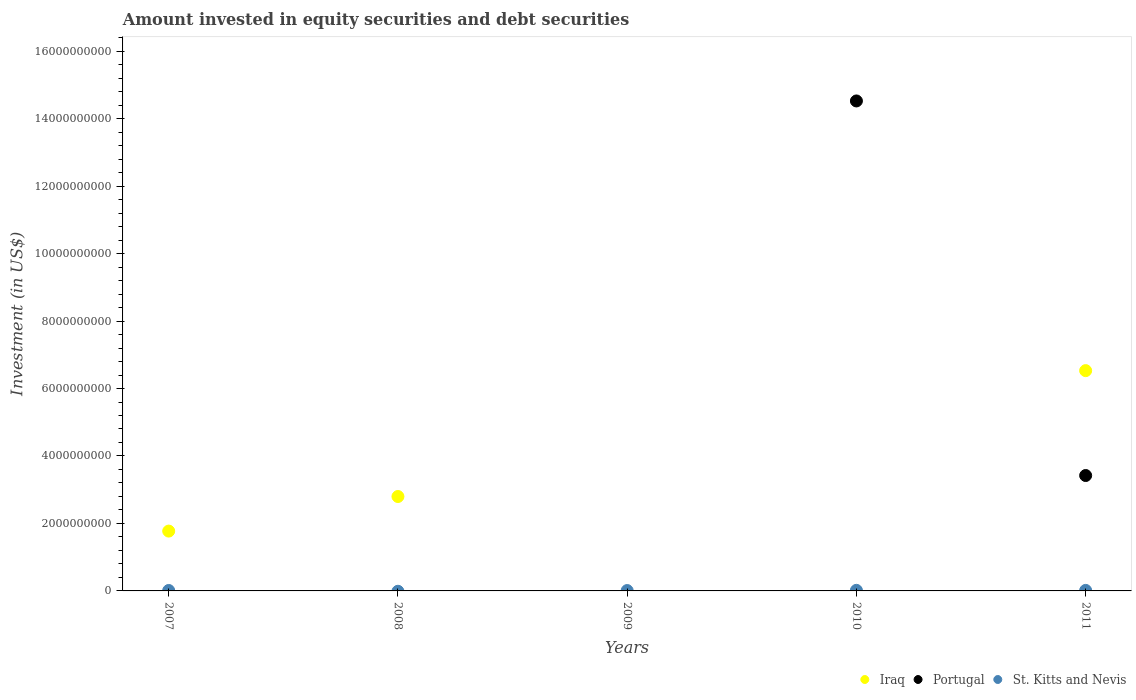Is the number of dotlines equal to the number of legend labels?
Give a very brief answer. No. What is the amount invested in equity securities and debt securities in Portugal in 2010?
Give a very brief answer. 1.45e+1. Across all years, what is the maximum amount invested in equity securities and debt securities in Portugal?
Provide a short and direct response. 1.45e+1. Across all years, what is the minimum amount invested in equity securities and debt securities in Iraq?
Give a very brief answer. 0. In which year was the amount invested in equity securities and debt securities in St. Kitts and Nevis maximum?
Give a very brief answer. 2010. What is the total amount invested in equity securities and debt securities in St. Kitts and Nevis in the graph?
Provide a succinct answer. 5.68e+07. What is the difference between the amount invested in equity securities and debt securities in St. Kitts and Nevis in 2007 and that in 2009?
Make the answer very short. 1.82e+06. What is the difference between the amount invested in equity securities and debt securities in Portugal in 2007 and the amount invested in equity securities and debt securities in Iraq in 2009?
Provide a succinct answer. 0. What is the average amount invested in equity securities and debt securities in St. Kitts and Nevis per year?
Your answer should be very brief. 1.14e+07. In the year 2011, what is the difference between the amount invested in equity securities and debt securities in Iraq and amount invested in equity securities and debt securities in St. Kitts and Nevis?
Make the answer very short. 6.51e+09. In how many years, is the amount invested in equity securities and debt securities in Iraq greater than 10000000000 US$?
Your answer should be very brief. 0. What is the ratio of the amount invested in equity securities and debt securities in Iraq in 2008 to that in 2011?
Offer a terse response. 0.43. What is the difference between the highest and the second highest amount invested in equity securities and debt securities in St. Kitts and Nevis?
Provide a succinct answer. 1.78e+06. What is the difference between the highest and the lowest amount invested in equity securities and debt securities in Portugal?
Provide a succinct answer. 1.45e+1. Is the amount invested in equity securities and debt securities in Portugal strictly greater than the amount invested in equity securities and debt securities in St. Kitts and Nevis over the years?
Offer a very short reply. No. How many dotlines are there?
Give a very brief answer. 3. Are the values on the major ticks of Y-axis written in scientific E-notation?
Your answer should be compact. No. Does the graph contain any zero values?
Provide a short and direct response. Yes. Where does the legend appear in the graph?
Your answer should be very brief. Bottom right. How many legend labels are there?
Your answer should be compact. 3. How are the legend labels stacked?
Your answer should be very brief. Horizontal. What is the title of the graph?
Your answer should be compact. Amount invested in equity securities and debt securities. What is the label or title of the X-axis?
Ensure brevity in your answer.  Years. What is the label or title of the Y-axis?
Provide a succinct answer. Investment (in US$). What is the Investment (in US$) of Iraq in 2007?
Offer a very short reply. 1.77e+09. What is the Investment (in US$) of St. Kitts and Nevis in 2007?
Provide a succinct answer. 1.30e+07. What is the Investment (in US$) in Iraq in 2008?
Offer a very short reply. 2.80e+09. What is the Investment (in US$) of Iraq in 2009?
Offer a very short reply. 0. What is the Investment (in US$) of St. Kitts and Nevis in 2009?
Offer a terse response. 1.12e+07. What is the Investment (in US$) of Portugal in 2010?
Make the answer very short. 1.45e+1. What is the Investment (in US$) of St. Kitts and Nevis in 2010?
Offer a very short reply. 1.72e+07. What is the Investment (in US$) in Iraq in 2011?
Keep it short and to the point. 6.53e+09. What is the Investment (in US$) in Portugal in 2011?
Make the answer very short. 3.42e+09. What is the Investment (in US$) of St. Kitts and Nevis in 2011?
Give a very brief answer. 1.55e+07. Across all years, what is the maximum Investment (in US$) in Iraq?
Keep it short and to the point. 6.53e+09. Across all years, what is the maximum Investment (in US$) in Portugal?
Provide a succinct answer. 1.45e+1. Across all years, what is the maximum Investment (in US$) of St. Kitts and Nevis?
Your response must be concise. 1.72e+07. Across all years, what is the minimum Investment (in US$) in Iraq?
Offer a very short reply. 0. Across all years, what is the minimum Investment (in US$) of Portugal?
Keep it short and to the point. 0. What is the total Investment (in US$) in Iraq in the graph?
Ensure brevity in your answer.  1.11e+1. What is the total Investment (in US$) of Portugal in the graph?
Your answer should be compact. 1.79e+1. What is the total Investment (in US$) of St. Kitts and Nevis in the graph?
Your answer should be compact. 5.68e+07. What is the difference between the Investment (in US$) in Iraq in 2007 and that in 2008?
Keep it short and to the point. -1.03e+09. What is the difference between the Investment (in US$) in St. Kitts and Nevis in 2007 and that in 2009?
Provide a short and direct response. 1.82e+06. What is the difference between the Investment (in US$) in St. Kitts and Nevis in 2007 and that in 2010?
Keep it short and to the point. -4.27e+06. What is the difference between the Investment (in US$) of Iraq in 2007 and that in 2011?
Make the answer very short. -4.76e+09. What is the difference between the Investment (in US$) in St. Kitts and Nevis in 2007 and that in 2011?
Give a very brief answer. -2.48e+06. What is the difference between the Investment (in US$) in Iraq in 2008 and that in 2011?
Give a very brief answer. -3.73e+09. What is the difference between the Investment (in US$) of St. Kitts and Nevis in 2009 and that in 2010?
Offer a very short reply. -6.08e+06. What is the difference between the Investment (in US$) of St. Kitts and Nevis in 2009 and that in 2011?
Provide a succinct answer. -4.30e+06. What is the difference between the Investment (in US$) in Portugal in 2010 and that in 2011?
Your answer should be very brief. 1.11e+1. What is the difference between the Investment (in US$) of St. Kitts and Nevis in 2010 and that in 2011?
Ensure brevity in your answer.  1.78e+06. What is the difference between the Investment (in US$) of Iraq in 2007 and the Investment (in US$) of St. Kitts and Nevis in 2009?
Your answer should be very brief. 1.76e+09. What is the difference between the Investment (in US$) of Iraq in 2007 and the Investment (in US$) of Portugal in 2010?
Provide a short and direct response. -1.28e+1. What is the difference between the Investment (in US$) in Iraq in 2007 and the Investment (in US$) in St. Kitts and Nevis in 2010?
Your answer should be compact. 1.76e+09. What is the difference between the Investment (in US$) of Iraq in 2007 and the Investment (in US$) of Portugal in 2011?
Ensure brevity in your answer.  -1.65e+09. What is the difference between the Investment (in US$) of Iraq in 2007 and the Investment (in US$) of St. Kitts and Nevis in 2011?
Your answer should be very brief. 1.76e+09. What is the difference between the Investment (in US$) in Iraq in 2008 and the Investment (in US$) in St. Kitts and Nevis in 2009?
Provide a short and direct response. 2.79e+09. What is the difference between the Investment (in US$) of Iraq in 2008 and the Investment (in US$) of Portugal in 2010?
Keep it short and to the point. -1.17e+1. What is the difference between the Investment (in US$) in Iraq in 2008 and the Investment (in US$) in St. Kitts and Nevis in 2010?
Your answer should be compact. 2.78e+09. What is the difference between the Investment (in US$) of Iraq in 2008 and the Investment (in US$) of Portugal in 2011?
Your answer should be very brief. -6.22e+08. What is the difference between the Investment (in US$) of Iraq in 2008 and the Investment (in US$) of St. Kitts and Nevis in 2011?
Give a very brief answer. 2.78e+09. What is the difference between the Investment (in US$) of Portugal in 2010 and the Investment (in US$) of St. Kitts and Nevis in 2011?
Your answer should be very brief. 1.45e+1. What is the average Investment (in US$) in Iraq per year?
Provide a succinct answer. 2.22e+09. What is the average Investment (in US$) in Portugal per year?
Keep it short and to the point. 3.59e+09. What is the average Investment (in US$) of St. Kitts and Nevis per year?
Ensure brevity in your answer.  1.14e+07. In the year 2007, what is the difference between the Investment (in US$) in Iraq and Investment (in US$) in St. Kitts and Nevis?
Give a very brief answer. 1.76e+09. In the year 2010, what is the difference between the Investment (in US$) of Portugal and Investment (in US$) of St. Kitts and Nevis?
Offer a terse response. 1.45e+1. In the year 2011, what is the difference between the Investment (in US$) of Iraq and Investment (in US$) of Portugal?
Provide a succinct answer. 3.11e+09. In the year 2011, what is the difference between the Investment (in US$) of Iraq and Investment (in US$) of St. Kitts and Nevis?
Make the answer very short. 6.51e+09. In the year 2011, what is the difference between the Investment (in US$) in Portugal and Investment (in US$) in St. Kitts and Nevis?
Offer a very short reply. 3.41e+09. What is the ratio of the Investment (in US$) in Iraq in 2007 to that in 2008?
Your answer should be compact. 0.63. What is the ratio of the Investment (in US$) in St. Kitts and Nevis in 2007 to that in 2009?
Your answer should be compact. 1.16. What is the ratio of the Investment (in US$) in St. Kitts and Nevis in 2007 to that in 2010?
Give a very brief answer. 0.75. What is the ratio of the Investment (in US$) in Iraq in 2007 to that in 2011?
Provide a succinct answer. 0.27. What is the ratio of the Investment (in US$) in St. Kitts and Nevis in 2007 to that in 2011?
Your answer should be very brief. 0.84. What is the ratio of the Investment (in US$) in Iraq in 2008 to that in 2011?
Your answer should be compact. 0.43. What is the ratio of the Investment (in US$) of St. Kitts and Nevis in 2009 to that in 2010?
Ensure brevity in your answer.  0.65. What is the ratio of the Investment (in US$) in St. Kitts and Nevis in 2009 to that in 2011?
Offer a terse response. 0.72. What is the ratio of the Investment (in US$) in Portugal in 2010 to that in 2011?
Keep it short and to the point. 4.25. What is the ratio of the Investment (in US$) in St. Kitts and Nevis in 2010 to that in 2011?
Make the answer very short. 1.12. What is the difference between the highest and the second highest Investment (in US$) in Iraq?
Give a very brief answer. 3.73e+09. What is the difference between the highest and the second highest Investment (in US$) of St. Kitts and Nevis?
Provide a succinct answer. 1.78e+06. What is the difference between the highest and the lowest Investment (in US$) in Iraq?
Provide a succinct answer. 6.53e+09. What is the difference between the highest and the lowest Investment (in US$) in Portugal?
Keep it short and to the point. 1.45e+1. What is the difference between the highest and the lowest Investment (in US$) in St. Kitts and Nevis?
Make the answer very short. 1.72e+07. 